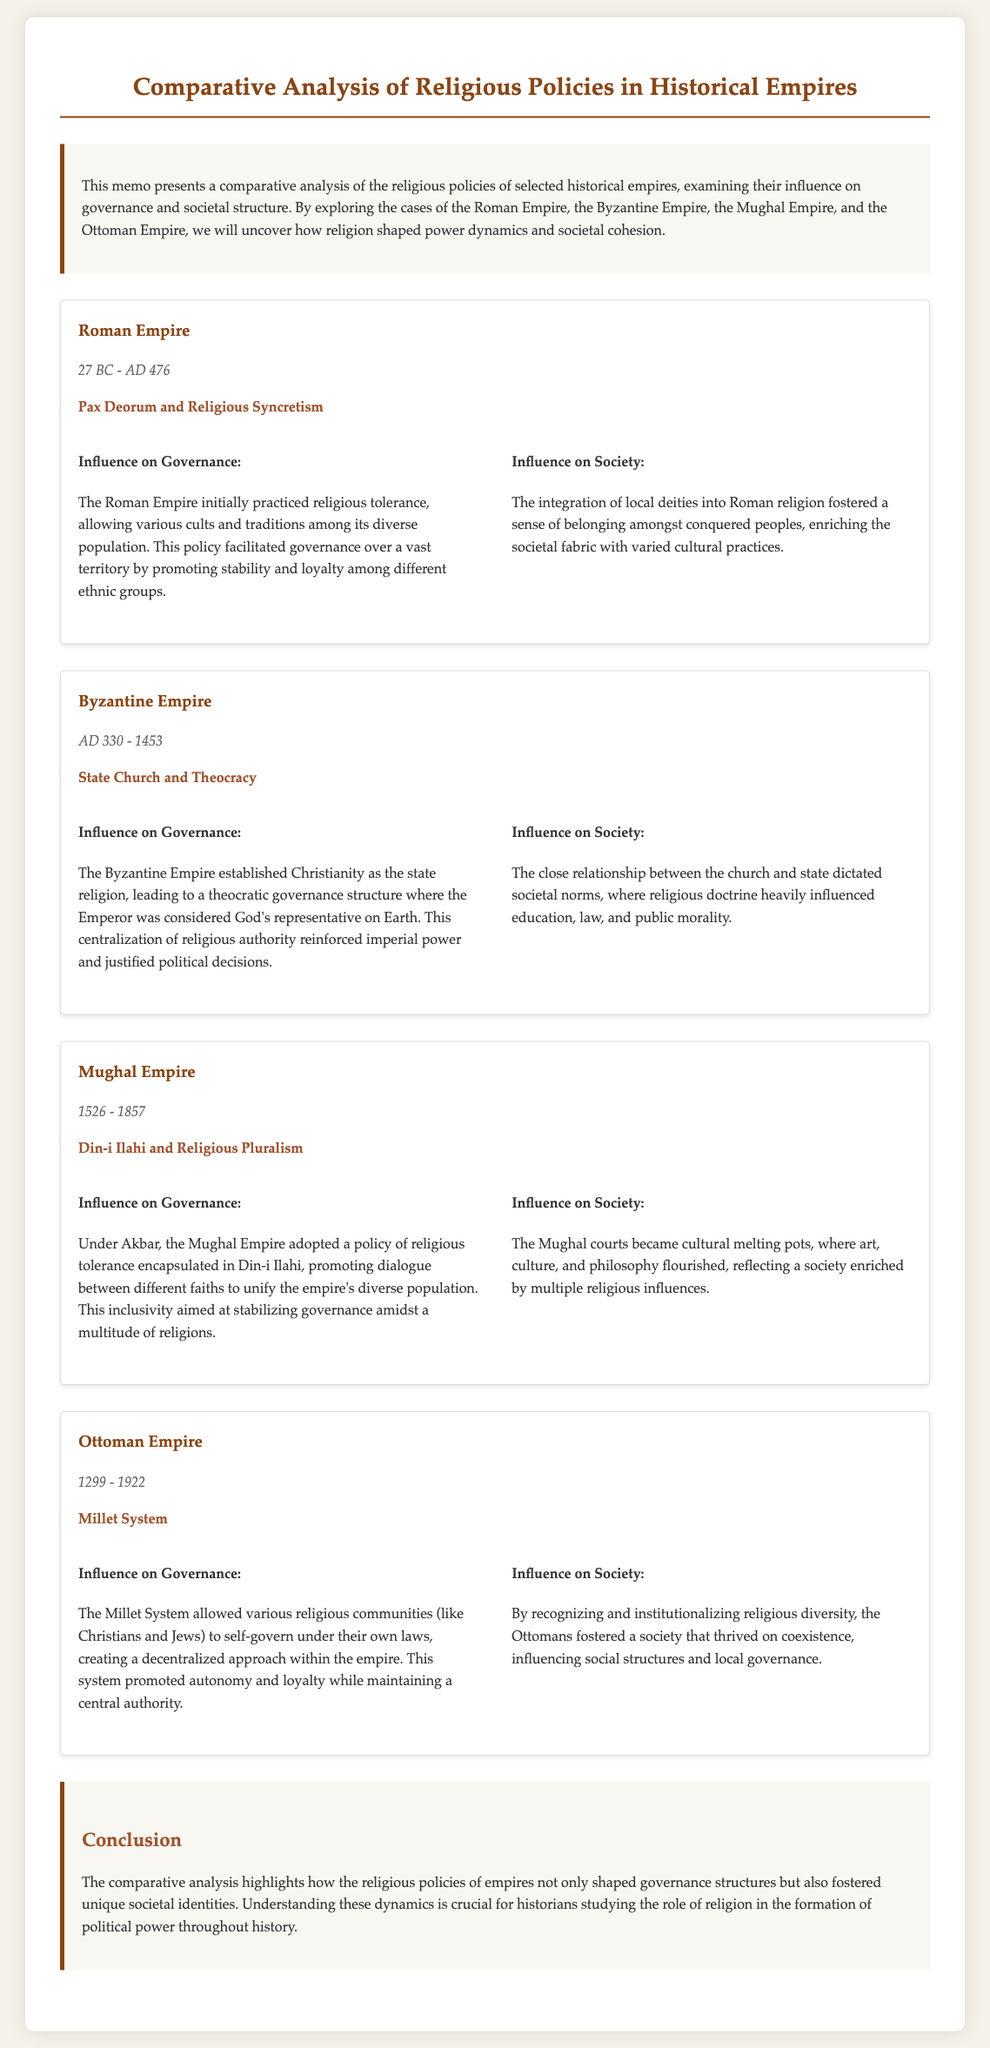What is the time period of the Roman Empire? The document states that the Roman Empire existed from 27 BC to AD 476.
Answer: 27 BC - AD 476 What religious policy did the Byzantine Empire establish? According to the document, the Byzantine Empire established Christianity as the state religion.
Answer: State Church Who was considered God's representative on Earth in the Byzantine Empire? The memo mentions that the Emperor was regarded as God's representative on Earth in the Byzantine Empire.
Answer: The Emperor What was the main religious policy promoted by Akbar in the Mughal Empire? The document indicates that Akbar promoted a policy known as Din-i Ilahi in the Mughal Empire.
Answer: Din-i Ilahi How did the Ottoman Empire's Millet System influence governance? The memo explains that the Millet System allowed various religious communities to self-govern, promoting a decentralized approach.
Answer: Decentralized approach What cultural aspect flourished in the Mughal courts? It is noted in the document that the Mughal courts became cultural melting pots, where art, culture, and philosophy flourished.
Answer: Cultural melting pots What was the influence of religion on societal norms in the Byzantine Empire? The document states that the close relationship between the church and state dictated societal norms influenced by religious doctrine.
Answer: Societal norms What conclusion is drawn about the role of religious policies in empires? The conclusion emphasizes that religious policies shaped governance structures and fostered unique societal identities.
Answer: Unique societal identities 